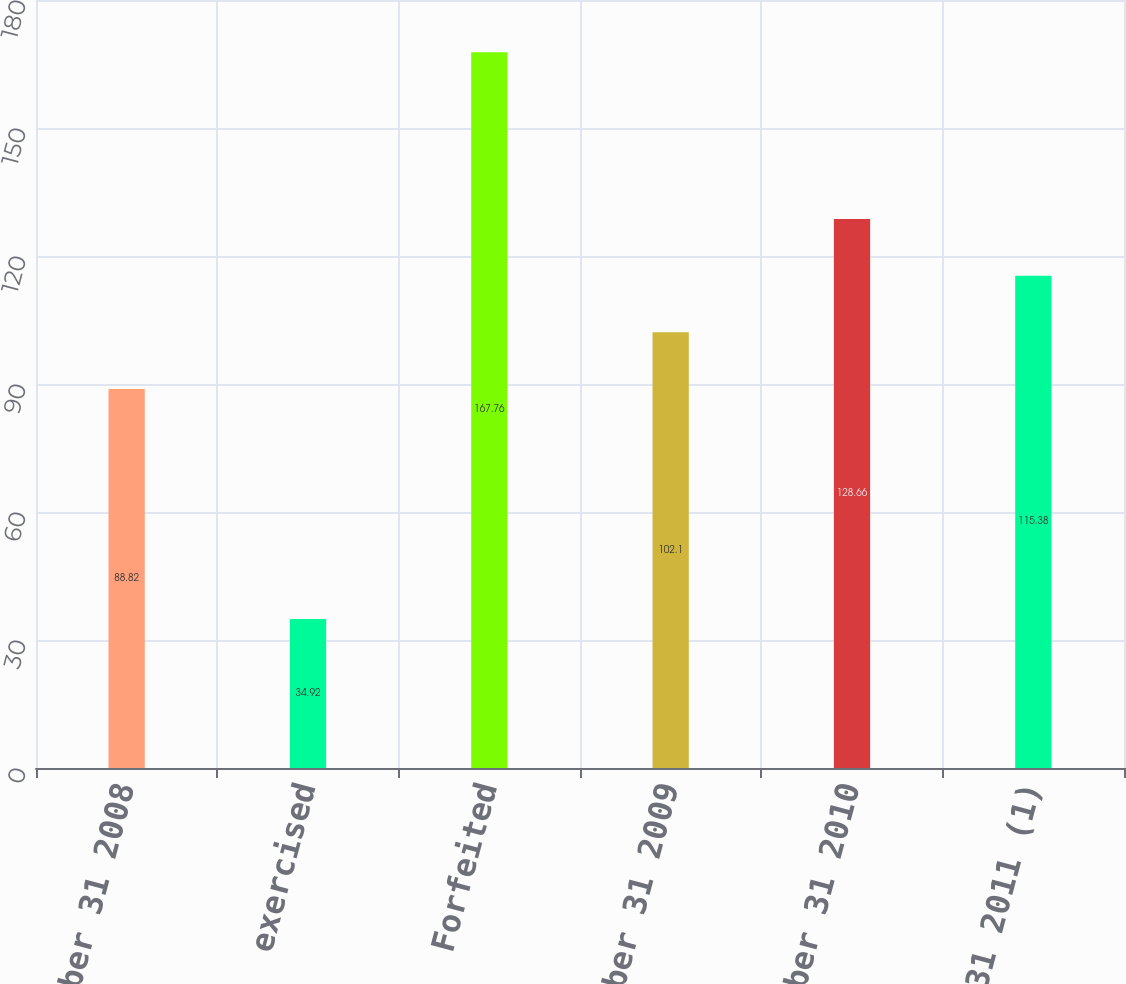Convert chart. <chart><loc_0><loc_0><loc_500><loc_500><bar_chart><fcel>december 31 2008<fcel>exercised<fcel>Forfeited<fcel>december 31 2009<fcel>december 31 2010<fcel>December 31 2011 (1)<nl><fcel>88.82<fcel>34.92<fcel>167.76<fcel>102.1<fcel>128.66<fcel>115.38<nl></chart> 